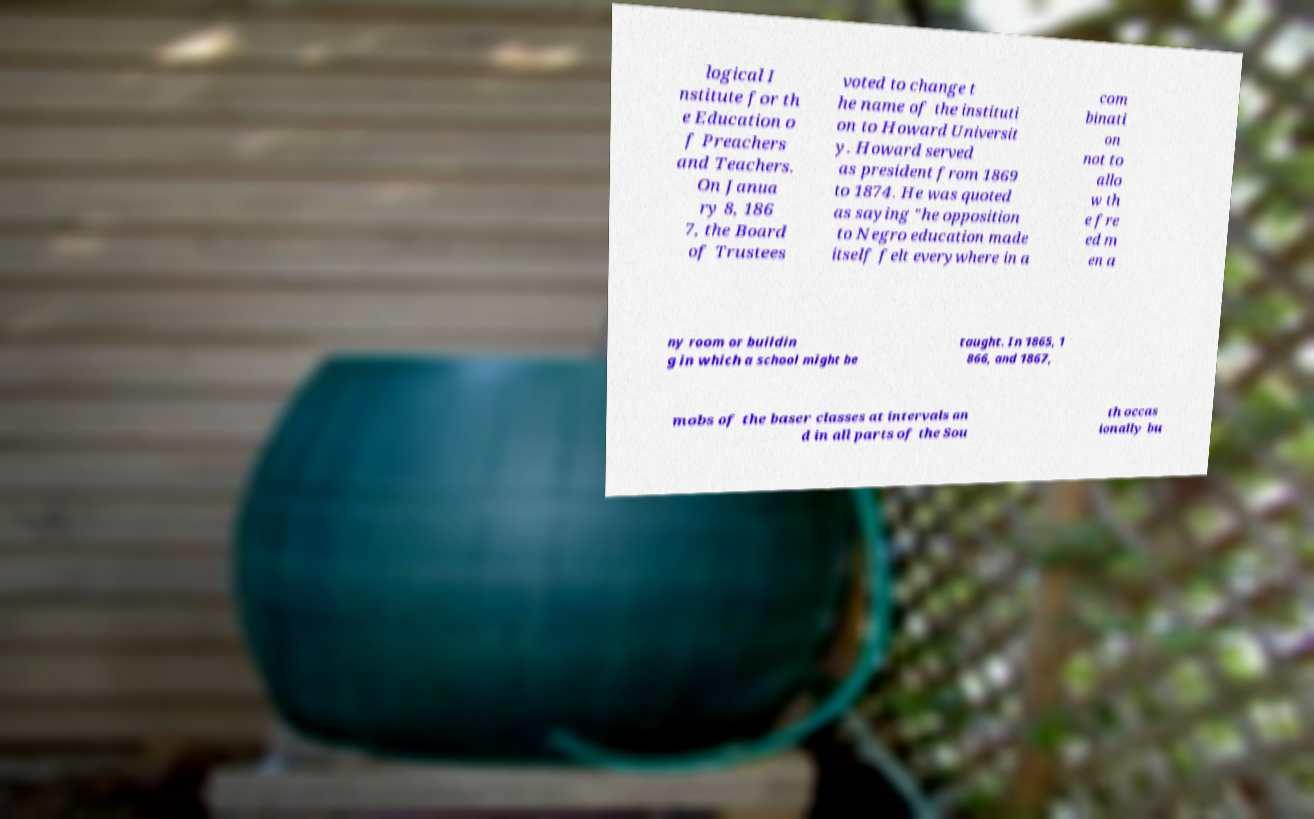Can you accurately transcribe the text from the provided image for me? logical I nstitute for th e Education o f Preachers and Teachers. On Janua ry 8, 186 7, the Board of Trustees voted to change t he name of the instituti on to Howard Universit y. Howard served as president from 1869 to 1874. He was quoted as saying "he opposition to Negro education made itself felt everywhere in a com binati on not to allo w th e fre ed m en a ny room or buildin g in which a school might be taught. In 1865, 1 866, and 1867, mobs of the baser classes at intervals an d in all parts of the Sou th occas ionally bu 